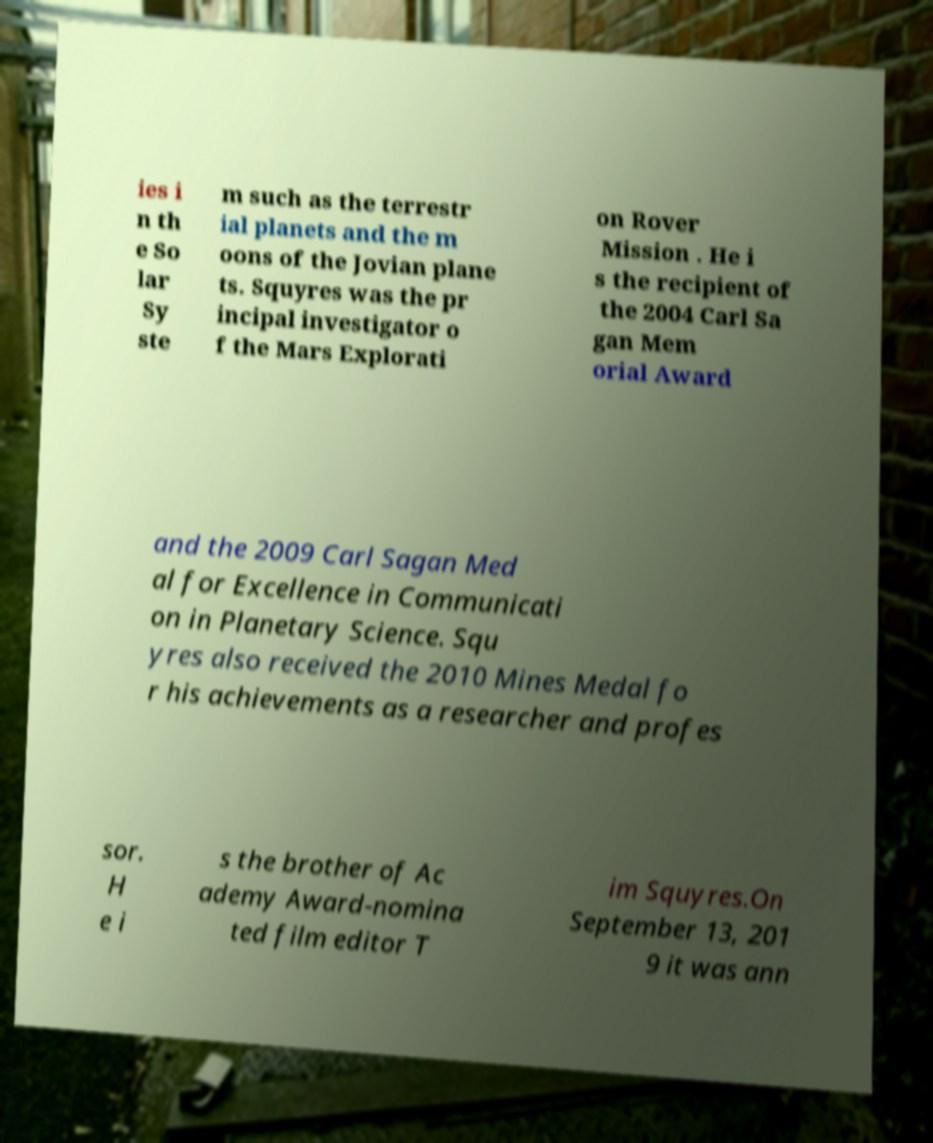Can you read and provide the text displayed in the image?This photo seems to have some interesting text. Can you extract and type it out for me? ies i n th e So lar Sy ste m such as the terrestr ial planets and the m oons of the Jovian plane ts. Squyres was the pr incipal investigator o f the Mars Explorati on Rover Mission . He i s the recipient of the 2004 Carl Sa gan Mem orial Award and the 2009 Carl Sagan Med al for Excellence in Communicati on in Planetary Science. Squ yres also received the 2010 Mines Medal fo r his achievements as a researcher and profes sor. H e i s the brother of Ac ademy Award-nomina ted film editor T im Squyres.On September 13, 201 9 it was ann 